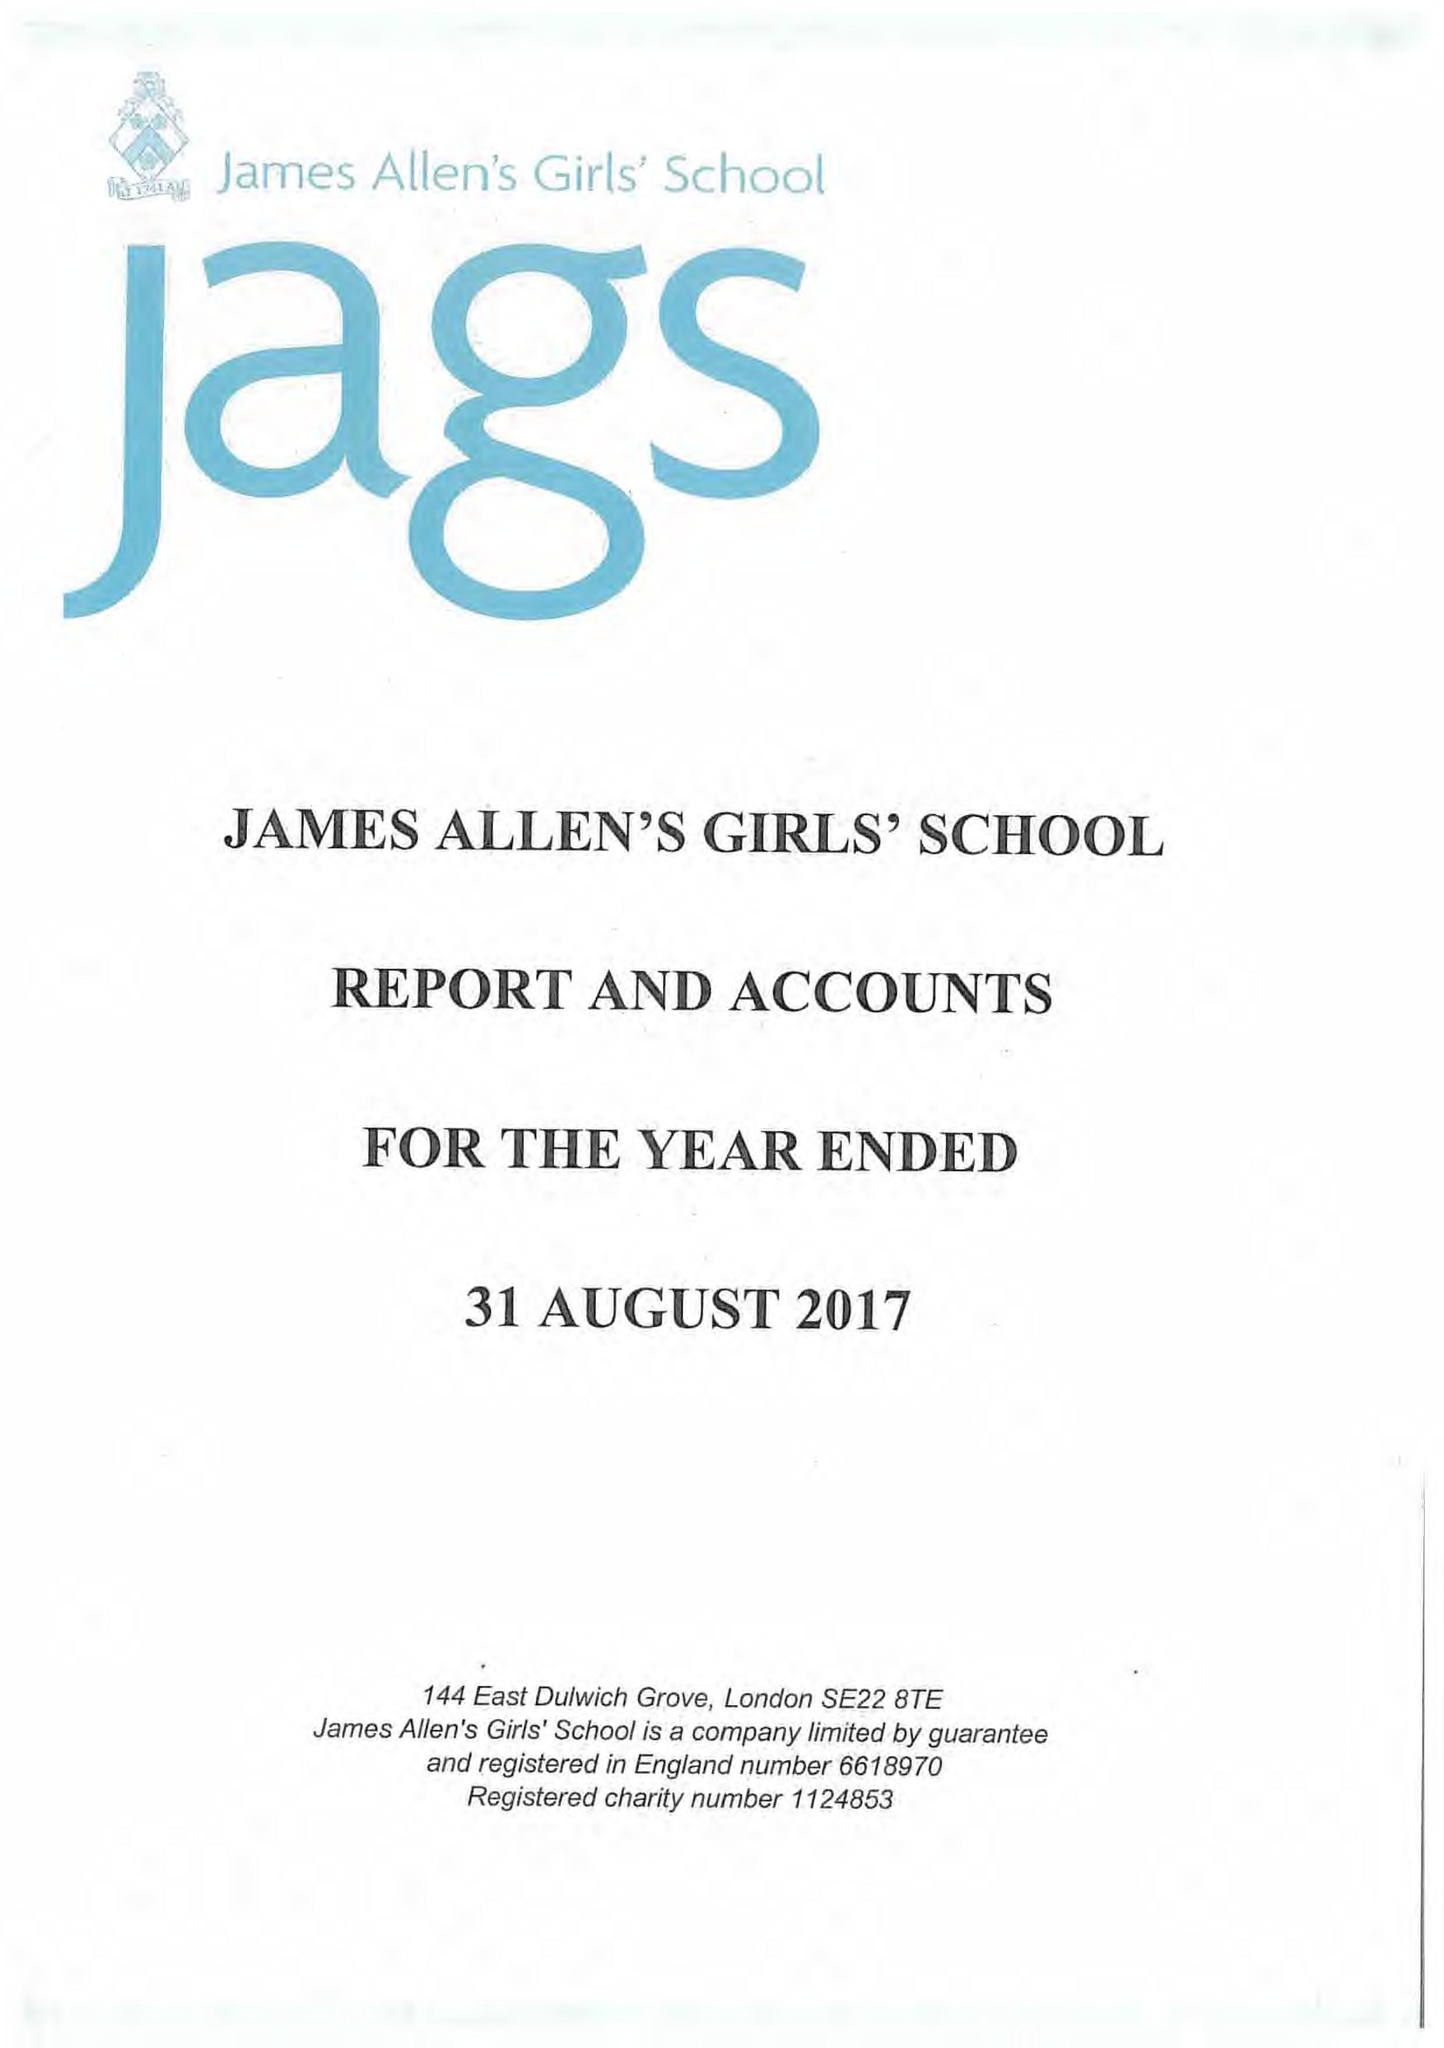What is the value for the charity_number?
Answer the question using a single word or phrase. 1124853 